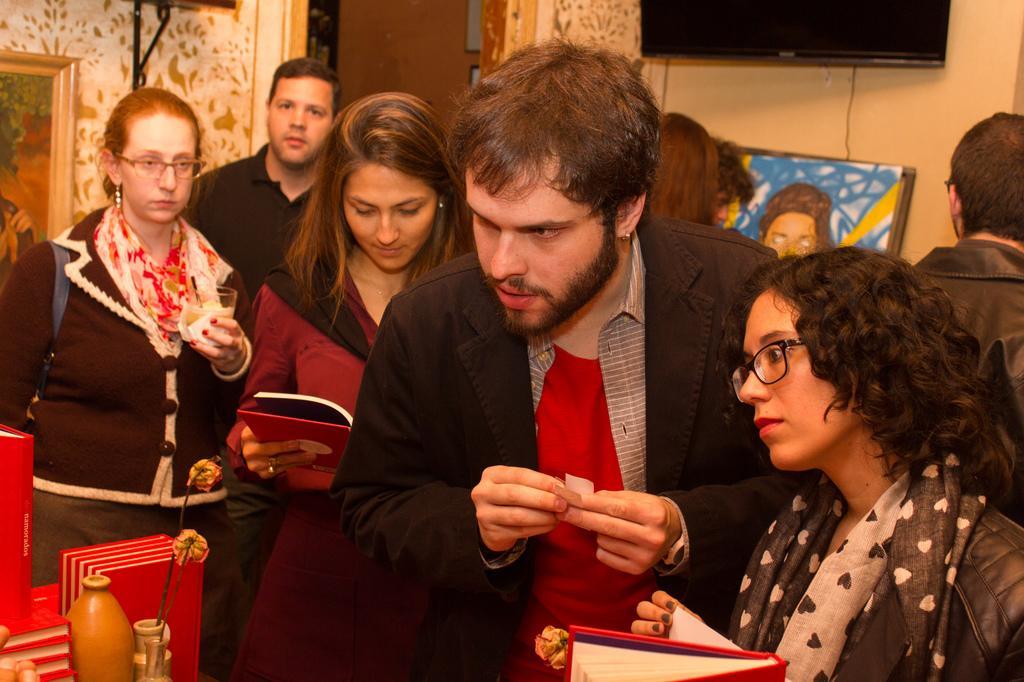In one or two sentences, can you explain what this image depicts? In this picture we can see some persons are standing, some of them are holding book, glass in there hand. In the background of the image we can see wall, photo frame, door, screen, painting board, wire are there. On the left side of the image we can see glass, dry flowers, books are there. 